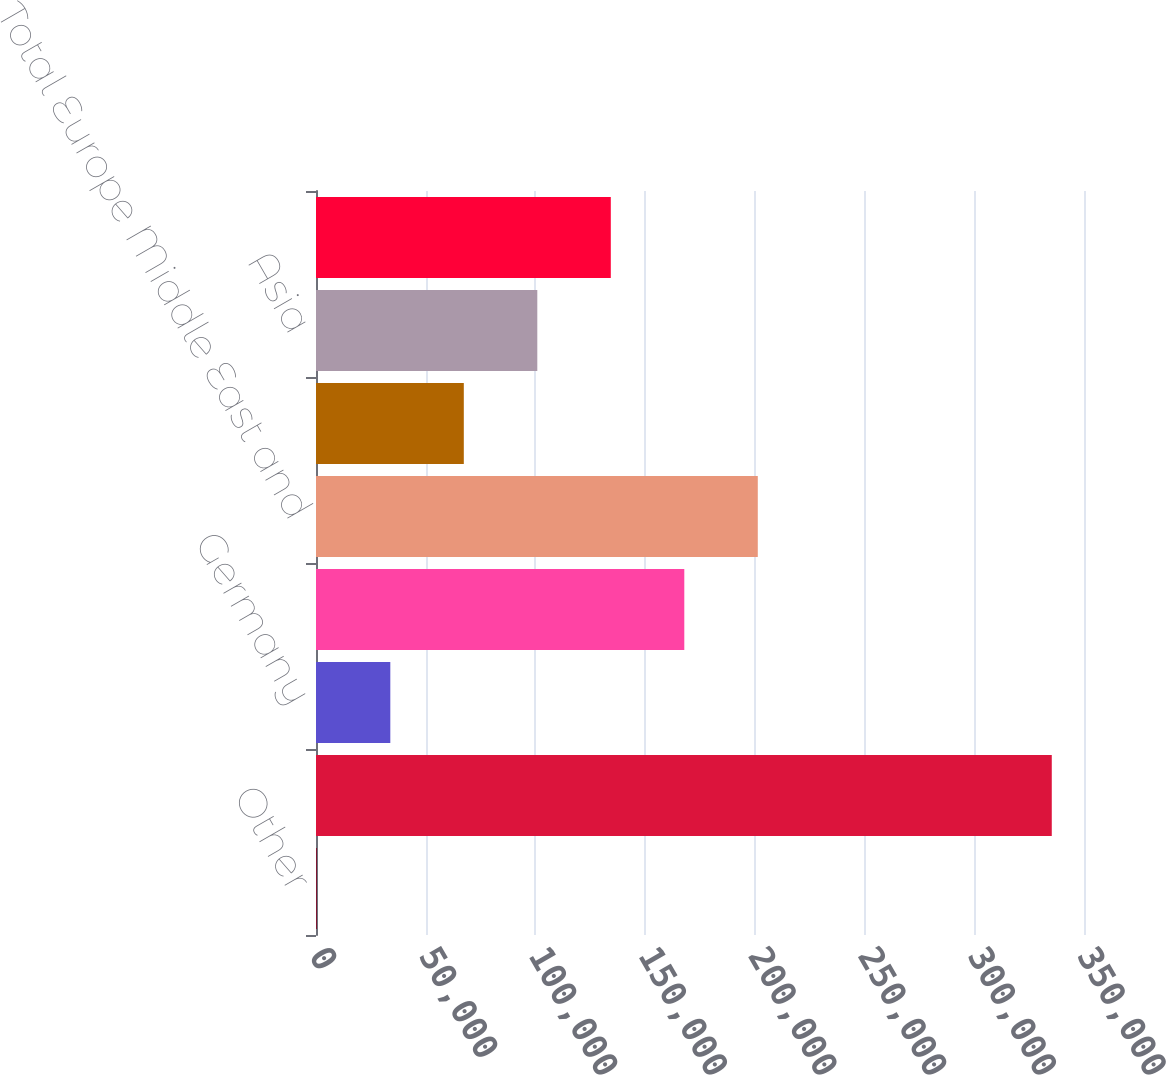<chart> <loc_0><loc_0><loc_500><loc_500><bar_chart><fcel>Other<fcel>Total North America<fcel>Germany<fcel>Other Europe Middle East and<fcel>Total Europe Middle East and<fcel>Japan<fcel>Asia<fcel>Total Japan and Asia<nl><fcel>371<fcel>335314<fcel>33865.3<fcel>167842<fcel>201337<fcel>67359.6<fcel>100854<fcel>134348<nl></chart> 